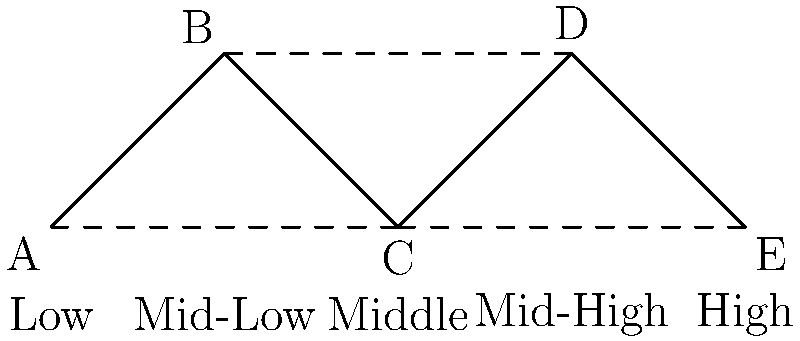In the graph above, vertices represent maternal health service centers in different socioeconomic areas, and edges represent direct connections between centers. What is the minimum number of centers that need to be removed to disconnect the low socioeconomic area (A) from the high socioeconomic area (E)? To solve this problem, we need to find the minimum cut between vertices A and E. Let's approach this step-by-step:

1. Identify all possible paths from A to E:
   - A -> B -> C -> D -> E
   - A -> C -> D -> E
   - A -> C -> E

2. Observe that all paths must go through vertex C. This means that C is a crucial connection point.

3. If we remove C, there is no way to reach E from A, as all paths are blocked.

4. Check if removing any other single vertex would disconnect A from E:
   - Removing A or E doesn't count as it's given in the question.
   - Removing B still leaves the path A -> C -> E.
   - Removing D still leaves the path A -> C -> E.

5. Therefore, C is the only vertex that, when removed, disconnects A from E.

The minimum number of centers that need to be removed is 1, which is center C representing the middle socioeconomic area.
Answer: 1 